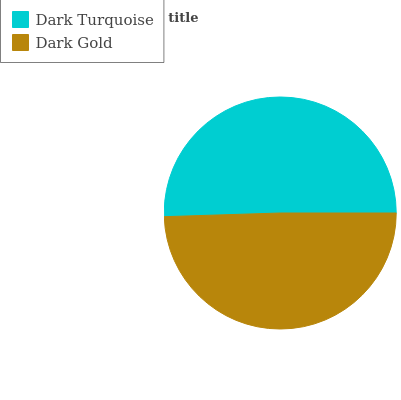Is Dark Gold the minimum?
Answer yes or no. Yes. Is Dark Turquoise the maximum?
Answer yes or no. Yes. Is Dark Gold the maximum?
Answer yes or no. No. Is Dark Turquoise greater than Dark Gold?
Answer yes or no. Yes. Is Dark Gold less than Dark Turquoise?
Answer yes or no. Yes. Is Dark Gold greater than Dark Turquoise?
Answer yes or no. No. Is Dark Turquoise less than Dark Gold?
Answer yes or no. No. Is Dark Turquoise the high median?
Answer yes or no. Yes. Is Dark Gold the low median?
Answer yes or no. Yes. Is Dark Gold the high median?
Answer yes or no. No. Is Dark Turquoise the low median?
Answer yes or no. No. 